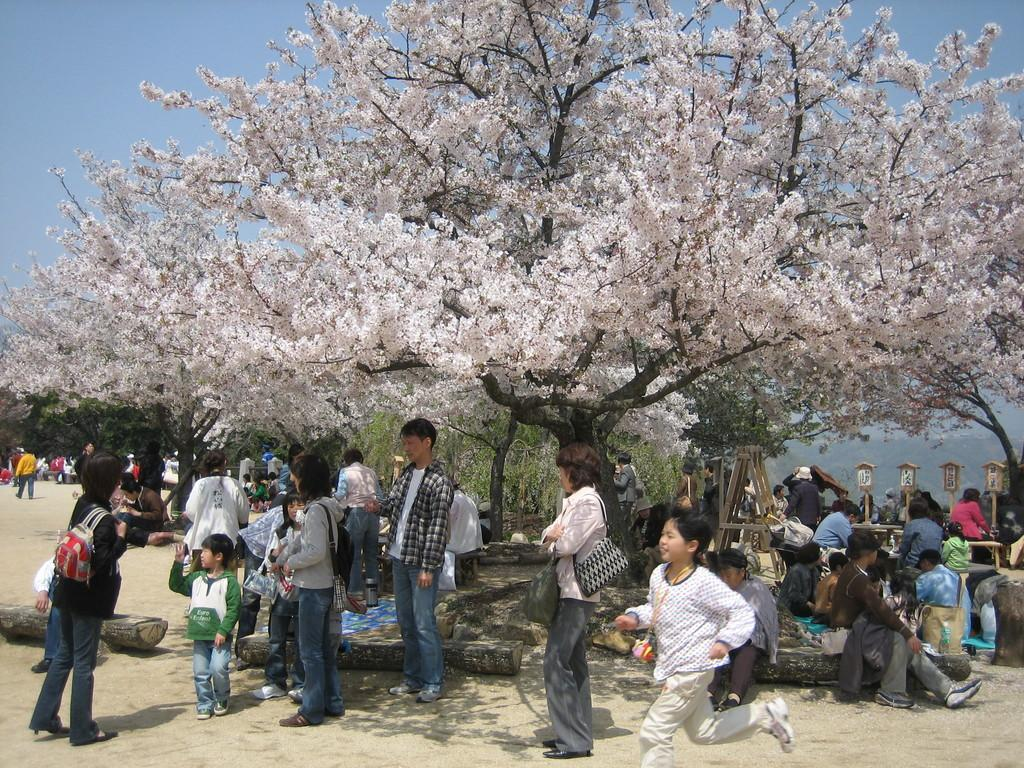How many people are in the image? There is a group of people in the image, but the exact number is not specified. What is on the ground in the image? There are wooden logs on the ground in the image. What can be seen in the background of the image? There are trees and the sky visible in the background of the image. Can you describe any objects in the background of the image? There are some unspecified objects in the background of the image. How long does it take for the minute to stretch across the sky in the image? There is no minute or stretching across the sky in the image. The sky is visible in the background, but it is not depicted as stretching or being affected by a minute. 